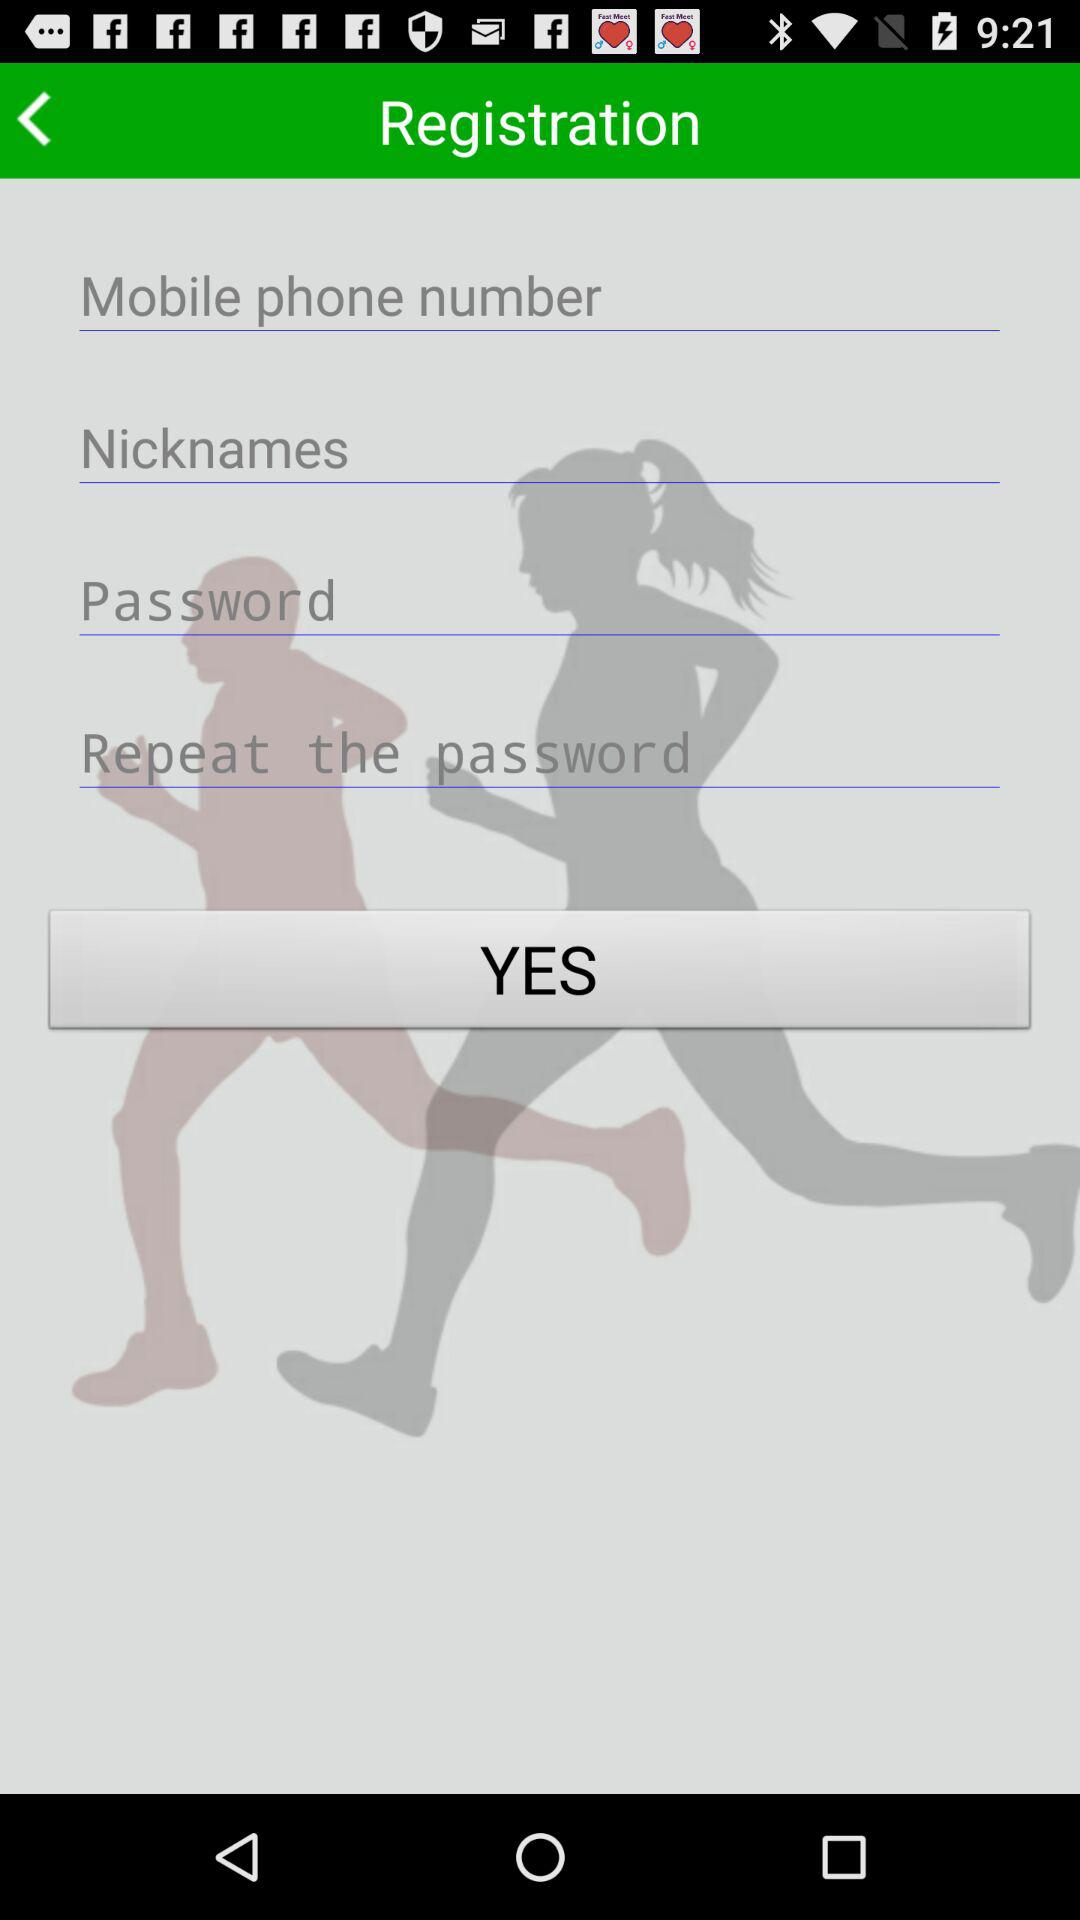How many text inputs are in the form?
Answer the question using a single word or phrase. 4 